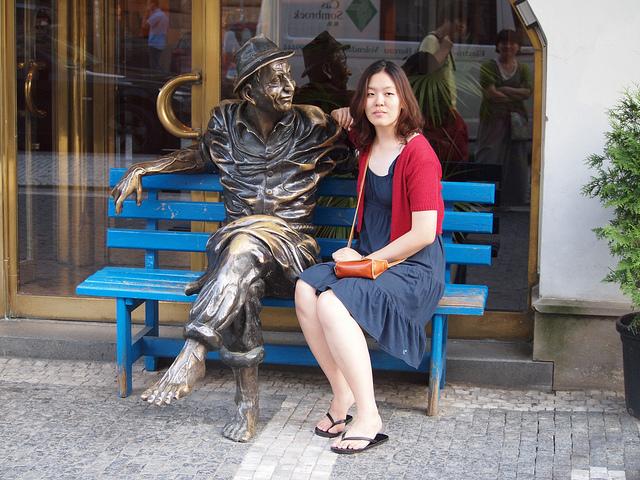What color is the ladies bag?
Answer briefly. Brown. Is the woman posing for a photo?
Answer briefly. Yes. Is the statue wearing socks?
Answer briefly. No. 